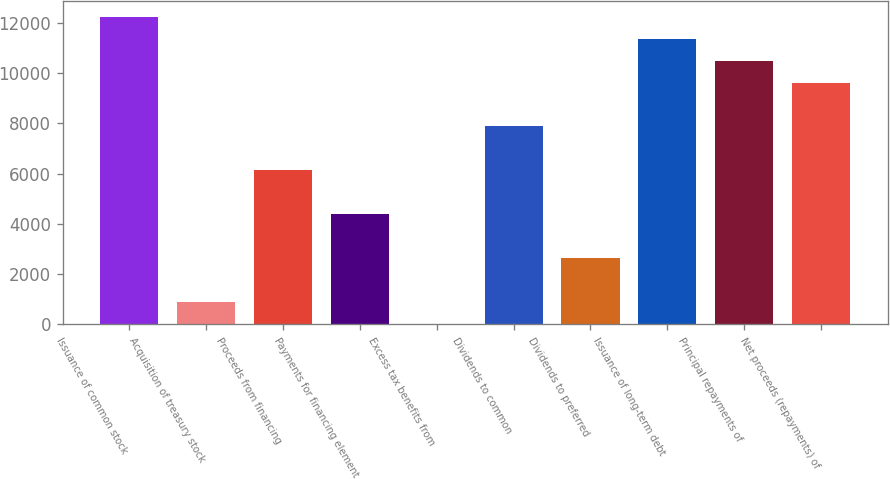Convert chart. <chart><loc_0><loc_0><loc_500><loc_500><bar_chart><fcel>Issuance of common stock<fcel>Acquisition of treasury stock<fcel>Proceeds from financing<fcel>Payments for financing element<fcel>Excess tax benefits from<fcel>Dividends to common<fcel>Dividends to preferred<fcel>Issuance of long-term debt<fcel>Principal repayments of<fcel>Net proceeds (repayments) of<nl><fcel>12253.7<fcel>875.45<fcel>6126.95<fcel>4376.45<fcel>0.2<fcel>7877.45<fcel>2625.95<fcel>11378.5<fcel>10503.2<fcel>9627.95<nl></chart> 